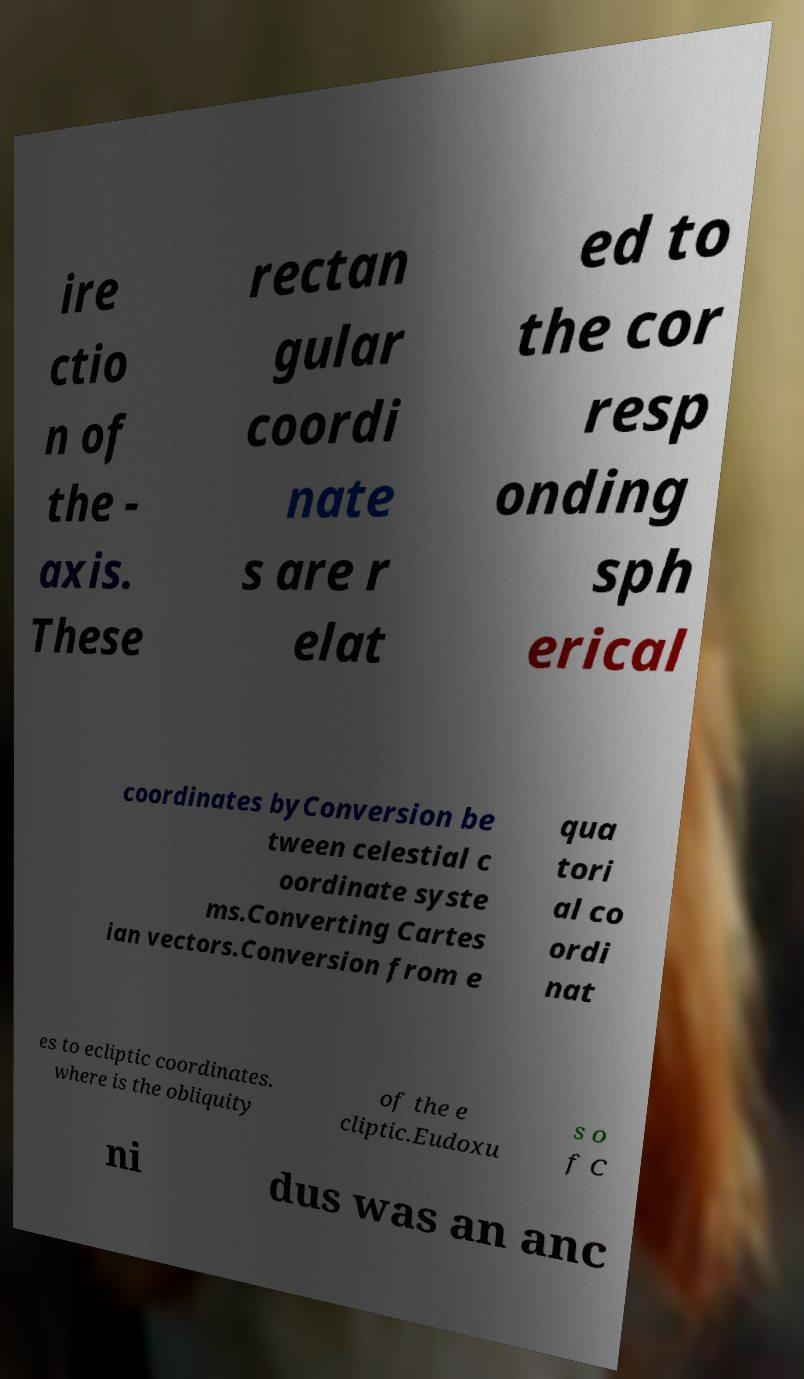What messages or text are displayed in this image? I need them in a readable, typed format. ire ctio n of the - axis. These rectan gular coordi nate s are r elat ed to the cor resp onding sph erical coordinates byConversion be tween celestial c oordinate syste ms.Converting Cartes ian vectors.Conversion from e qua tori al co ordi nat es to ecliptic coordinates. where is the obliquity of the e cliptic.Eudoxu s o f C ni dus was an anc 